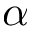Convert formula to latex. <formula><loc_0><loc_0><loc_500><loc_500>\alpha</formula> 